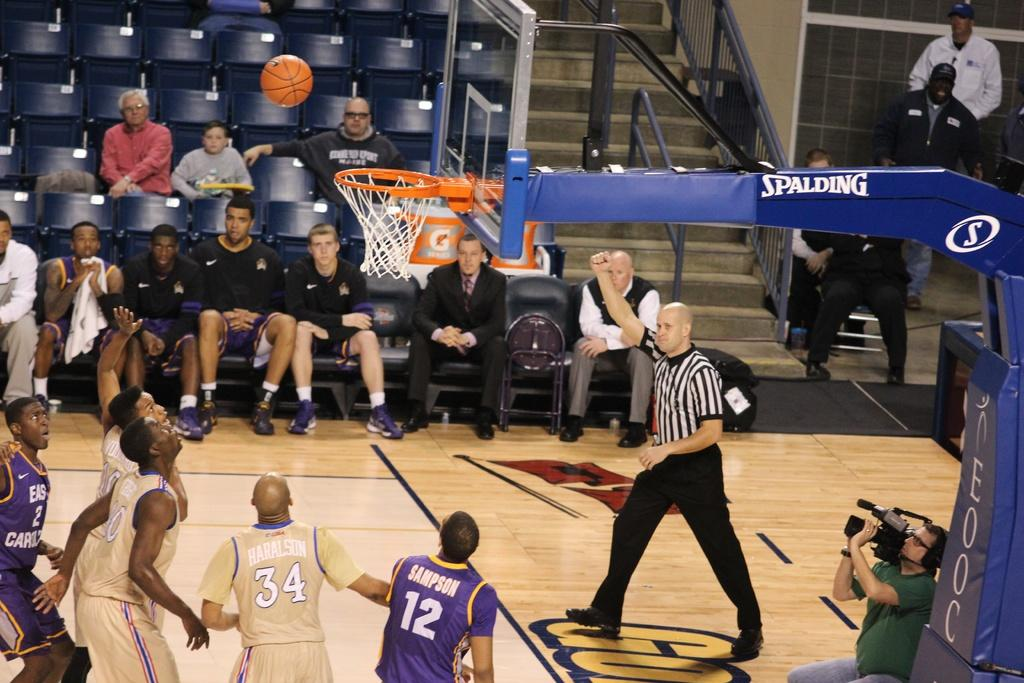<image>
Write a terse but informative summary of the picture. the number 12 is on the jersey of a person 